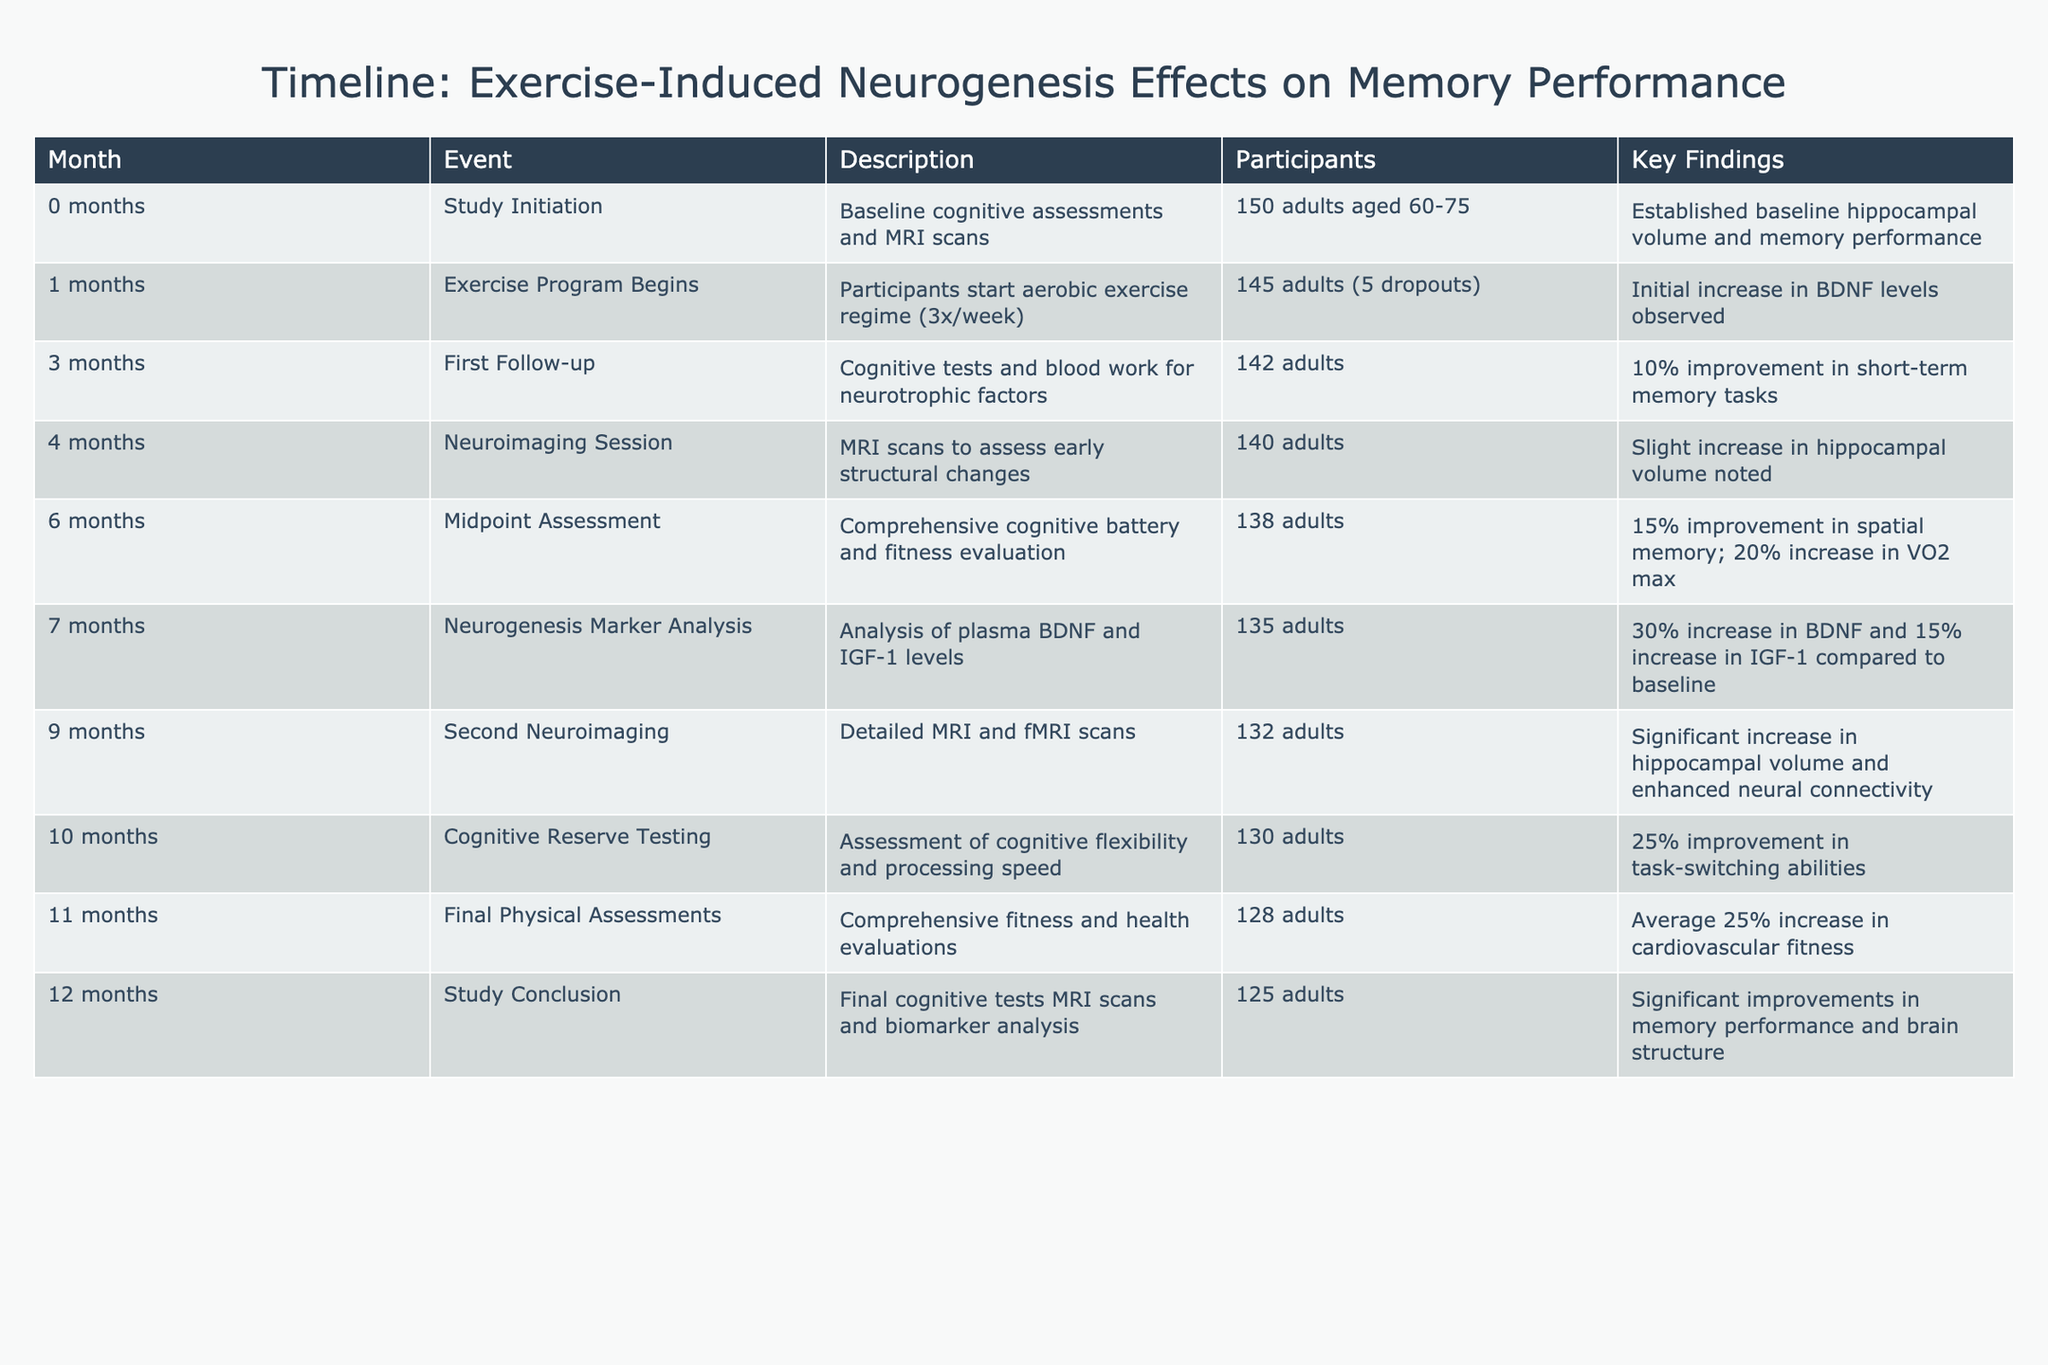What was the study initiation month? The study initiation month is reported as "0," indicating that it is the baseline or starting point of the study. This is clearly stated in the Month column.
Answer: 0 What percentage improvement in short-term memory tasks was observed at the first follow-up? The first follow-up, noted at month 3, indicates a 10% improvement in short-term memory tasks. This value is directly mentioned in the Key Findings column for that month.
Answer: 10% How many participants remained in the study by the final month? At the final month (12), the number of participants is recorded as 125. This is a straightforward retrieval from the Participants column for month 12.
Answer: 125 What was the average improvement in cardiovascular fitness observed by month 11? The final physical assessments conducted in month 11 reported an average increase of 25% in cardiovascular fitness. The Key Findings from month 11 clearly indicate this increase.
Answer: 25% Was there a significant increase in hippocampal volume noted at the second neuroimaging session (month 9)? Yes, the data from month 9 specifies a "significant increase" in hippocampal volume, indicating that this fact is true based on the Key Findings for that month.
Answer: Yes What was the total decrease in participants from the study initiation to the study conclusion? The study started with 150 participants (month 0) and concluded with 125 participants (month 12). To find the decrease, we calculate 150 - 125 = 25, representing the total decrease in participants.
Answer: 25 How did the BDNF levels change by month 7 compared to baseline? In month 7, there was a 30% increase in BDNF levels compared to baseline levels. This value is given in the Key Findings for that month, allowing us to answer the question directly.
Answer: 30% What improvements in spatial memory were noted at the midpoint assessment (month 6)? The midpoint assessment reported a 15% improvement in spatial memory. This percentage is present in the Key Findings for month 6, confirming the improvement observed at that point in the study.
Answer: 15% 